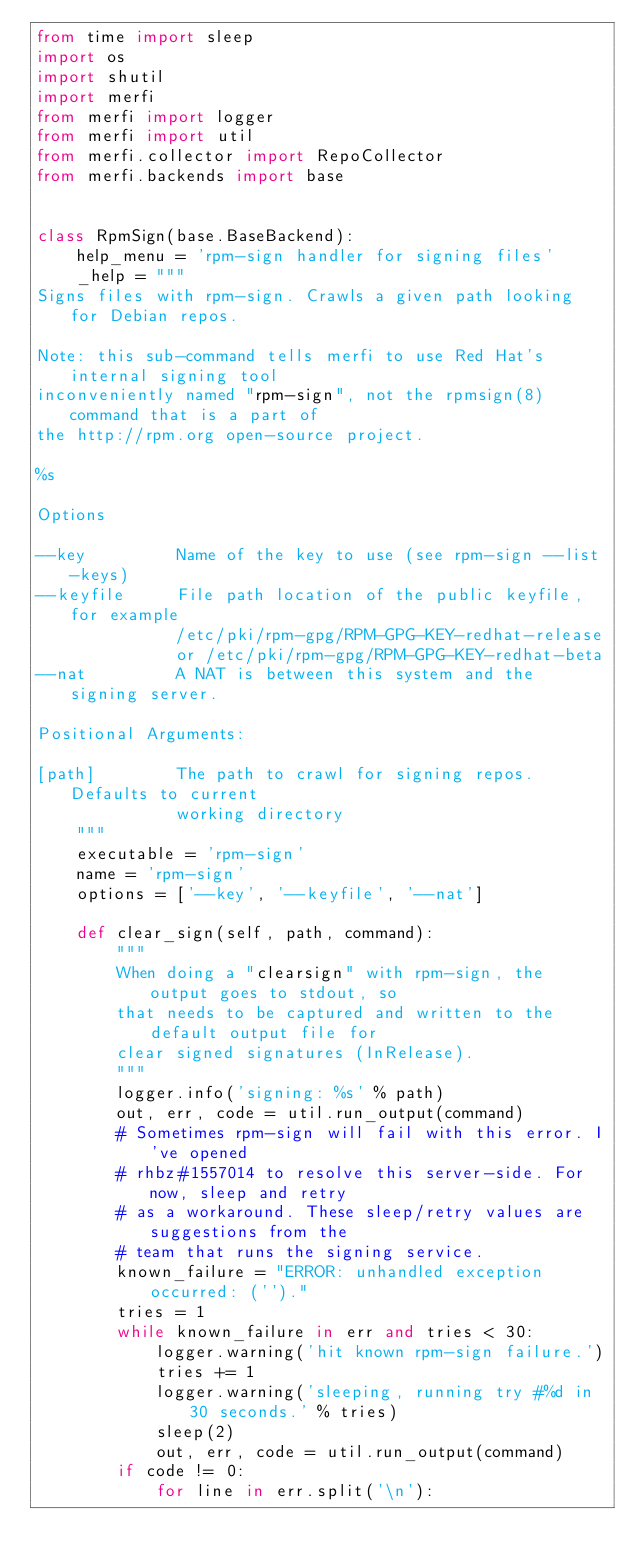<code> <loc_0><loc_0><loc_500><loc_500><_Python_>from time import sleep
import os
import shutil
import merfi
from merfi import logger
from merfi import util
from merfi.collector import RepoCollector
from merfi.backends import base


class RpmSign(base.BaseBackend):
    help_menu = 'rpm-sign handler for signing files'
    _help = """
Signs files with rpm-sign. Crawls a given path looking for Debian repos.

Note: this sub-command tells merfi to use Red Hat's internal signing tool
inconveniently named "rpm-sign", not the rpmsign(8) command that is a part of
the http://rpm.org open-source project.

%s

Options

--key         Name of the key to use (see rpm-sign --list-keys)
--keyfile     File path location of the public keyfile, for example
              /etc/pki/rpm-gpg/RPM-GPG-KEY-redhat-release
              or /etc/pki/rpm-gpg/RPM-GPG-KEY-redhat-beta
--nat         A NAT is between this system and the signing server.

Positional Arguments:

[path]        The path to crawl for signing repos. Defaults to current
              working directory
    """
    executable = 'rpm-sign'
    name = 'rpm-sign'
    options = ['--key', '--keyfile', '--nat']

    def clear_sign(self, path, command):
        """
        When doing a "clearsign" with rpm-sign, the output goes to stdout, so
        that needs to be captured and written to the default output file for
        clear signed signatures (InRelease).
        """
        logger.info('signing: %s' % path)
        out, err, code = util.run_output(command)
        # Sometimes rpm-sign will fail with this error. I've opened
        # rhbz#1557014 to resolve this server-side. For now, sleep and retry
        # as a workaround. These sleep/retry values are suggestions from the
        # team that runs the signing service.
        known_failure = "ERROR: unhandled exception occurred: ('')."
        tries = 1
        while known_failure in err and tries < 30:
            logger.warning('hit known rpm-sign failure.')
            tries += 1
            logger.warning('sleeping, running try #%d in 30 seconds.' % tries)
            sleep(2)
            out, err, code = util.run_output(command)
        if code != 0:
            for line in err.split('\n'):</code> 